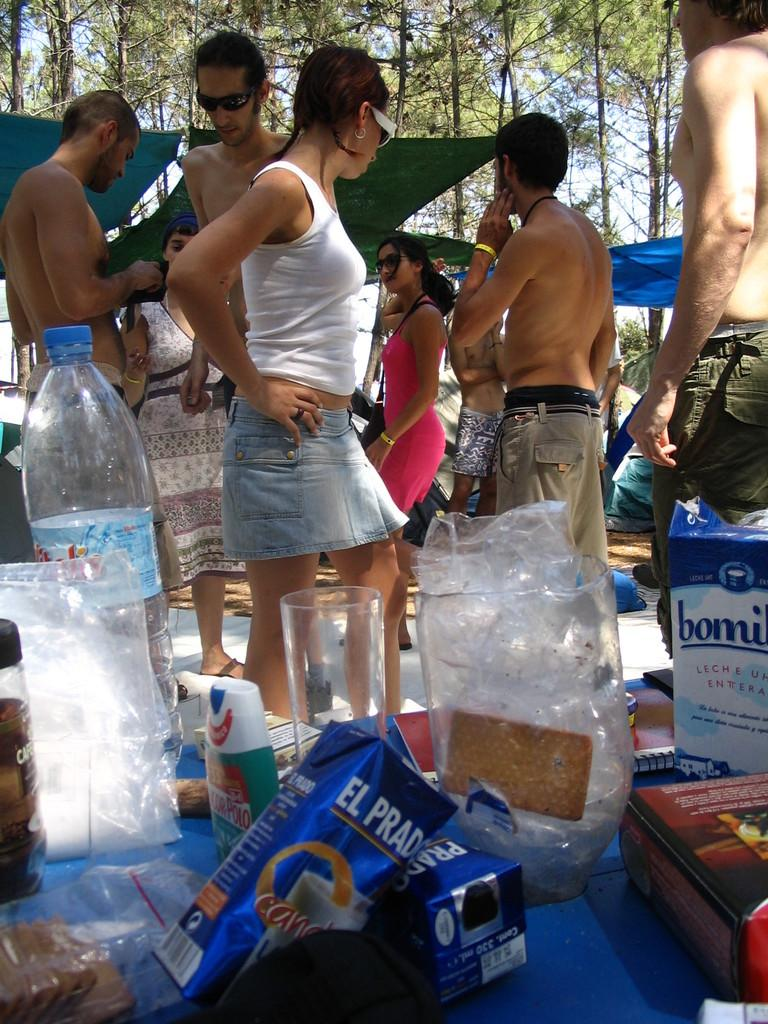What are the people in the image standing on? The people in the image are standing on the ground. What items are in front of the people? There is a water bottle, glasses, and food items in front of them. What can be seen behind the people? There are trees, the sky, and tents behind them. Can you tell me how many copies of the book the bear is holding in the image? There is no book or bear present in the image. Who is the friend standing next to the people in the image? There is no friend mentioned or visible in the image. 